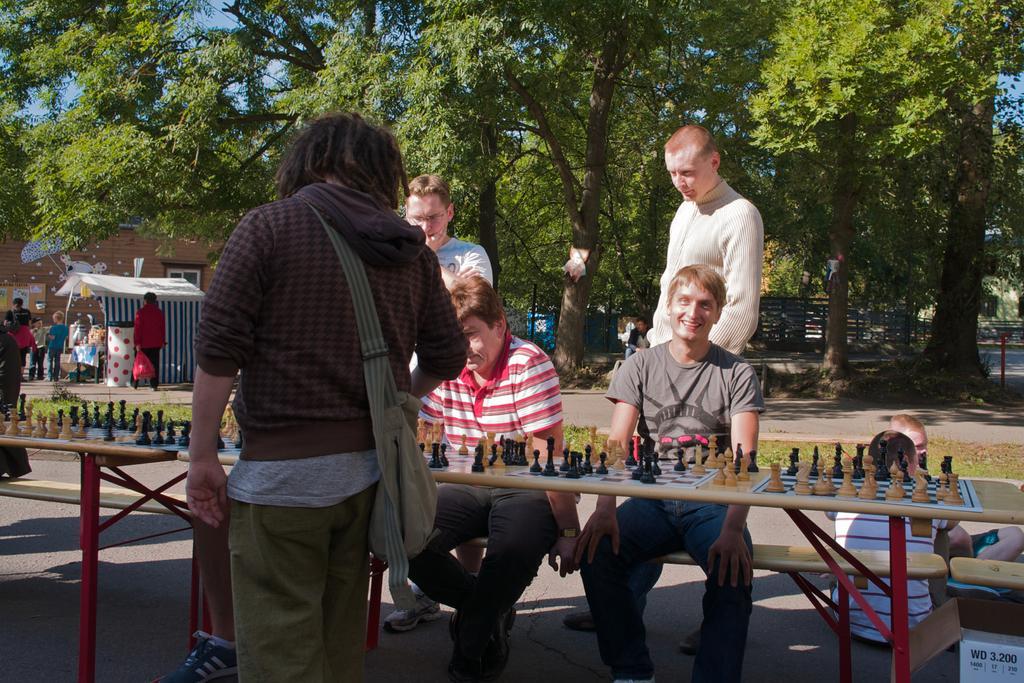Please provide a concise description of this image. In this image there is the sky towards the top of the image, there are trees, there is a building towards the left of the image, there is a tent, there are a group of persons standing, there are tables, there are chess boards on the table, there are coins, there are two men sitting, there are three men standing, there is a man wearing a bag, there are two persons sitting on the ground. 